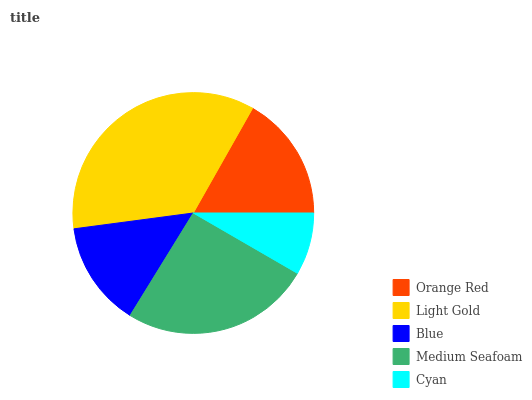Is Cyan the minimum?
Answer yes or no. Yes. Is Light Gold the maximum?
Answer yes or no. Yes. Is Blue the minimum?
Answer yes or no. No. Is Blue the maximum?
Answer yes or no. No. Is Light Gold greater than Blue?
Answer yes or no. Yes. Is Blue less than Light Gold?
Answer yes or no. Yes. Is Blue greater than Light Gold?
Answer yes or no. No. Is Light Gold less than Blue?
Answer yes or no. No. Is Orange Red the high median?
Answer yes or no. Yes. Is Orange Red the low median?
Answer yes or no. Yes. Is Medium Seafoam the high median?
Answer yes or no. No. Is Cyan the low median?
Answer yes or no. No. 